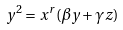Convert formula to latex. <formula><loc_0><loc_0><loc_500><loc_500>y ^ { 2 } = x ^ { r } ( \beta y + \gamma z )</formula> 